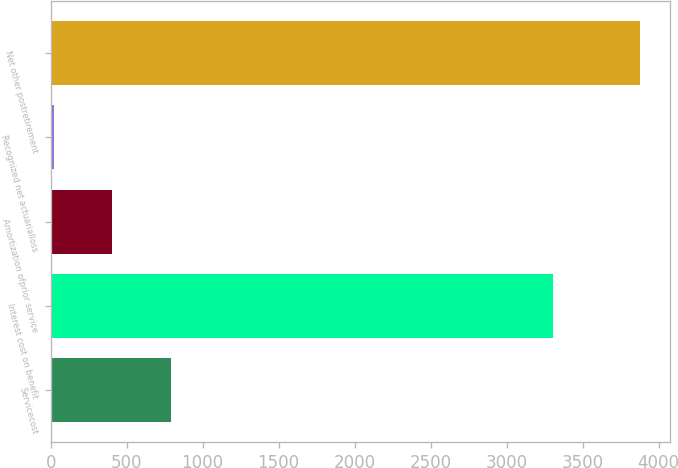<chart> <loc_0><loc_0><loc_500><loc_500><bar_chart><fcel>Servicecost<fcel>Interest cost on benefit<fcel>Amortization ofprior service<fcel>Recognized net actuarialloss<fcel>Net other postretirement<nl><fcel>791<fcel>3302<fcel>405<fcel>19<fcel>3879<nl></chart> 